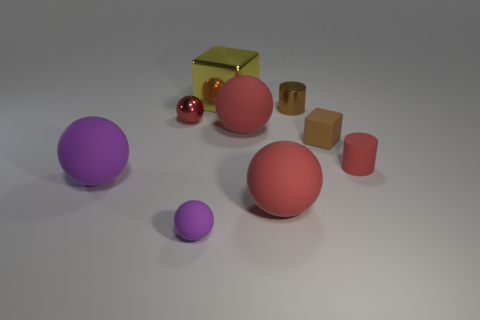How many purple spheres must be subtracted to get 1 purple spheres? 1 Subtract all gray cubes. How many red spheres are left? 3 Subtract all small matte balls. How many balls are left? 4 Subtract all cyan balls. Subtract all red blocks. How many balls are left? 5 Add 1 red balls. How many objects exist? 10 Subtract all blocks. How many objects are left? 7 Add 9 small purple spheres. How many small purple spheres exist? 10 Subtract 0 green cylinders. How many objects are left? 9 Subtract all small purple balls. Subtract all purple spheres. How many objects are left? 6 Add 3 tiny matte objects. How many tiny matte objects are left? 6 